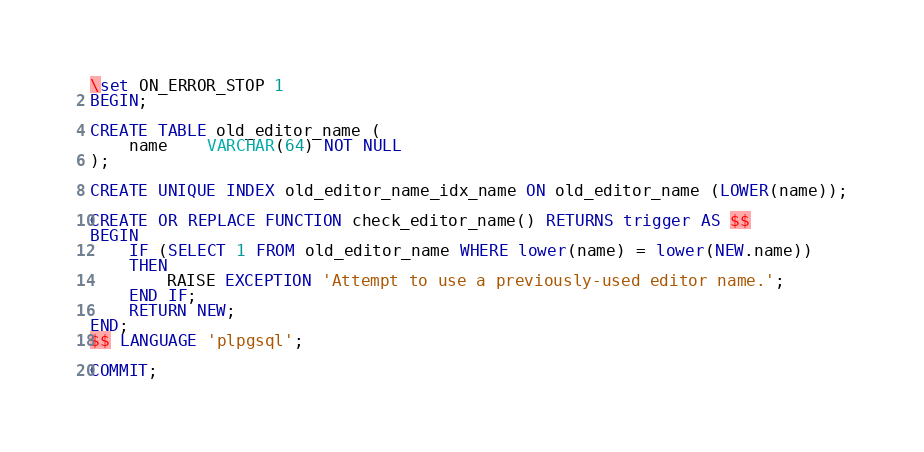Convert code to text. <code><loc_0><loc_0><loc_500><loc_500><_SQL_>\set ON_ERROR_STOP 1
BEGIN;

CREATE TABLE old_editor_name (
    name    VARCHAR(64) NOT NULL
);

CREATE UNIQUE INDEX old_editor_name_idx_name ON old_editor_name (LOWER(name));

CREATE OR REPLACE FUNCTION check_editor_name() RETURNS trigger AS $$
BEGIN
    IF (SELECT 1 FROM old_editor_name WHERE lower(name) = lower(NEW.name))
    THEN
        RAISE EXCEPTION 'Attempt to use a previously-used editor name.';
    END IF;
    RETURN NEW;
END;
$$ LANGUAGE 'plpgsql';

COMMIT;
</code> 